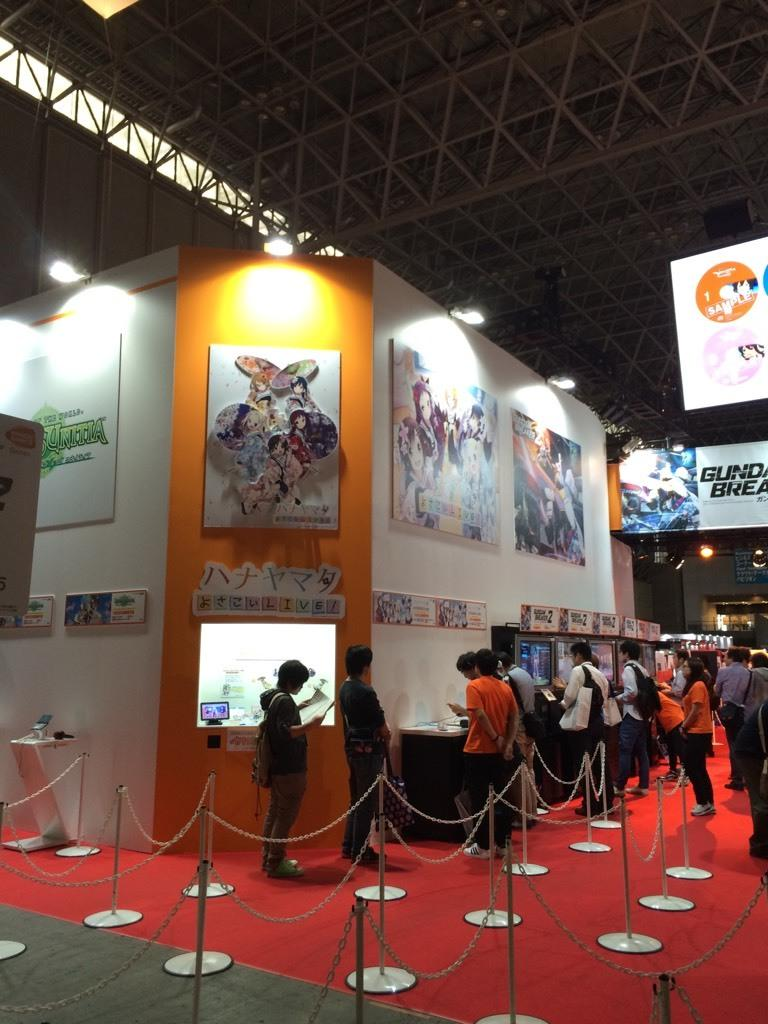What is the color of the surface that the people are standing on in the image? The people are standing on a red surface in the image. What are some of the people doing in the image? Some of the people are carrying bags. What can be seen in the background of the image? In the background of the image, there are boards, lights, a wall, and a fence. Are there any other objects visible in the background of the image? Yes, there are other unspecified objects in the background of the image. What type of snow can be seen falling in the image? There is no snow present in the image; it takes place on a red surface with people standing on it and various objects in the background. 